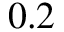<formula> <loc_0><loc_0><loc_500><loc_500>0 . 2</formula> 